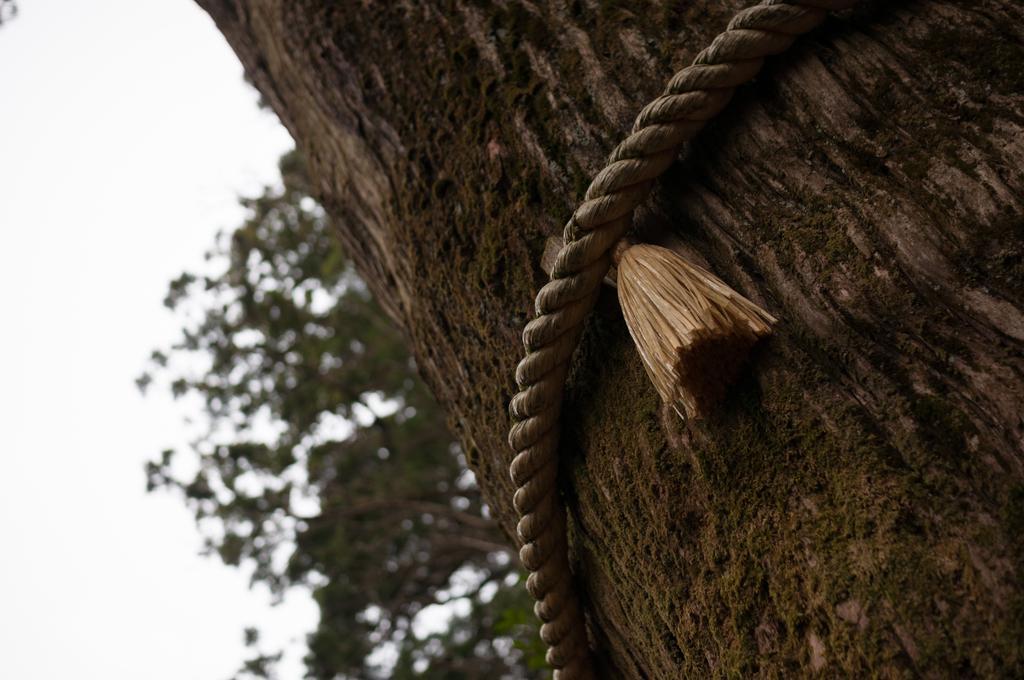Could you give a brief overview of what you see in this image? In this image there is a rope which is tied to the tree. In the background there are green leaves. 